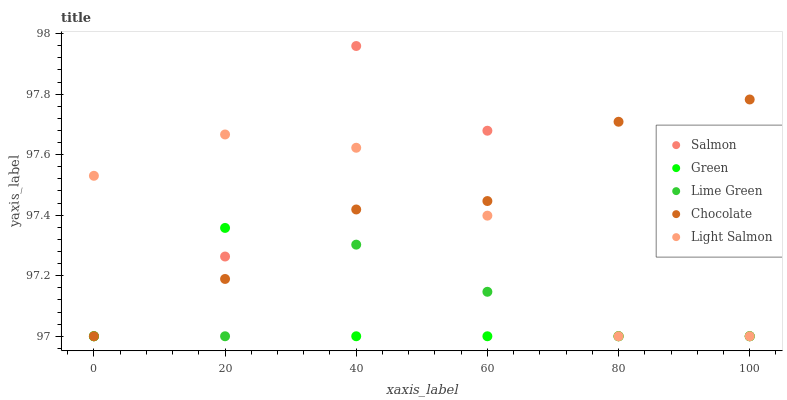Does Green have the minimum area under the curve?
Answer yes or no. Yes. Does Chocolate have the maximum area under the curve?
Answer yes or no. Yes. Does Light Salmon have the minimum area under the curve?
Answer yes or no. No. Does Light Salmon have the maximum area under the curve?
Answer yes or no. No. Is Chocolate the smoothest?
Answer yes or no. Yes. Is Salmon the roughest?
Answer yes or no. Yes. Is Light Salmon the smoothest?
Answer yes or no. No. Is Light Salmon the roughest?
Answer yes or no. No. Does Green have the lowest value?
Answer yes or no. Yes. Does Salmon have the highest value?
Answer yes or no. Yes. Does Light Salmon have the highest value?
Answer yes or no. No. Does Chocolate intersect Light Salmon?
Answer yes or no. Yes. Is Chocolate less than Light Salmon?
Answer yes or no. No. Is Chocolate greater than Light Salmon?
Answer yes or no. No. 